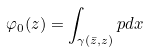<formula> <loc_0><loc_0><loc_500><loc_500>\varphi _ { 0 } ( z ) = \int _ { \gamma ( \bar { z } , z ) } p d x \text { }</formula> 